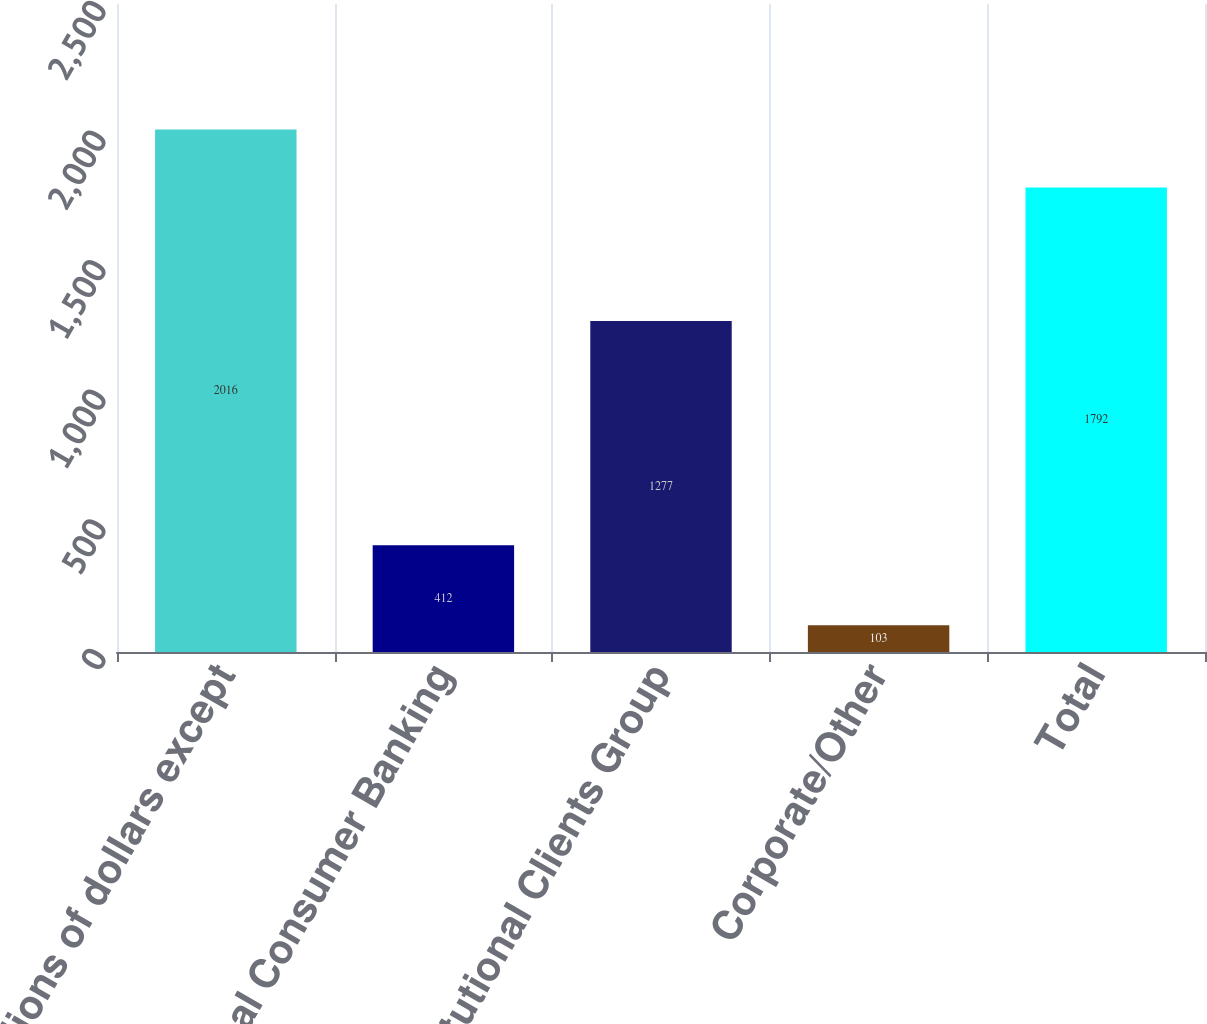<chart> <loc_0><loc_0><loc_500><loc_500><bar_chart><fcel>In millions of dollars except<fcel>Global Consumer Banking<fcel>Institutional Clients Group<fcel>Corporate/Other<fcel>Total<nl><fcel>2016<fcel>412<fcel>1277<fcel>103<fcel>1792<nl></chart> 